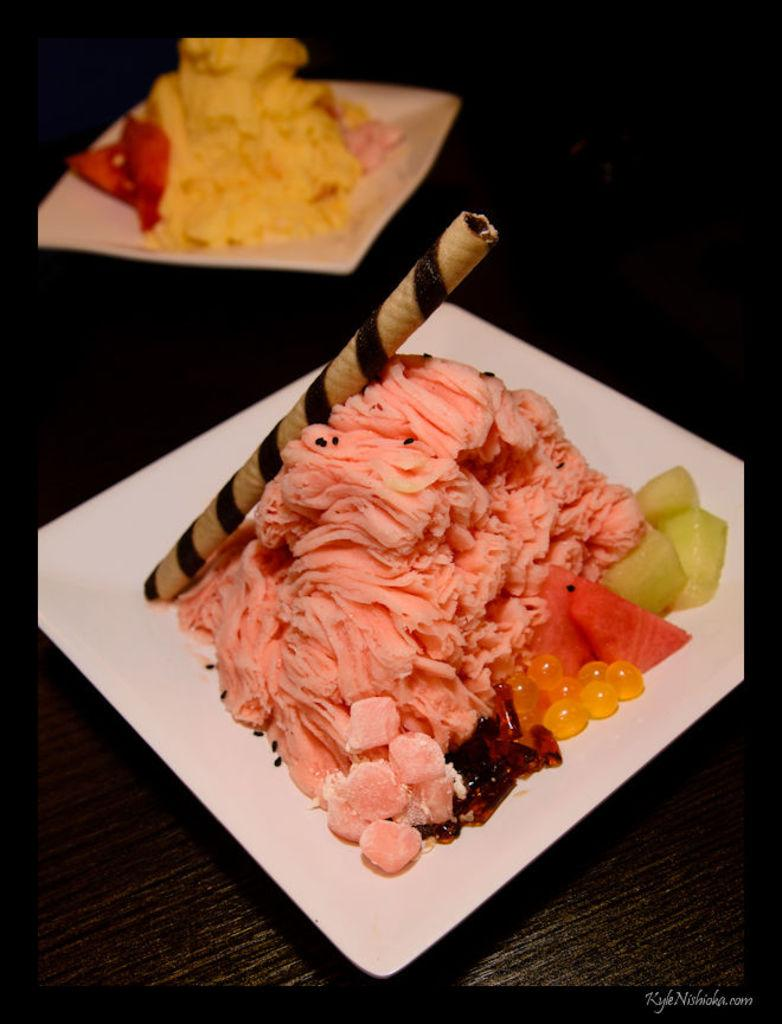What is present on the plates in the image? There is food in the plates in the image. What day of the week is depicted in the image? The image does not depict a specific day of the week; it only shows food on plates. How many people are present in the image? The number of people cannot be determined from the image, as it only shows food on plates. 